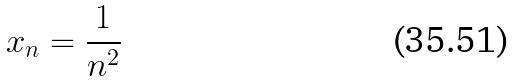<formula> <loc_0><loc_0><loc_500><loc_500>x _ { n } = \frac { 1 } { n ^ { 2 } }</formula> 